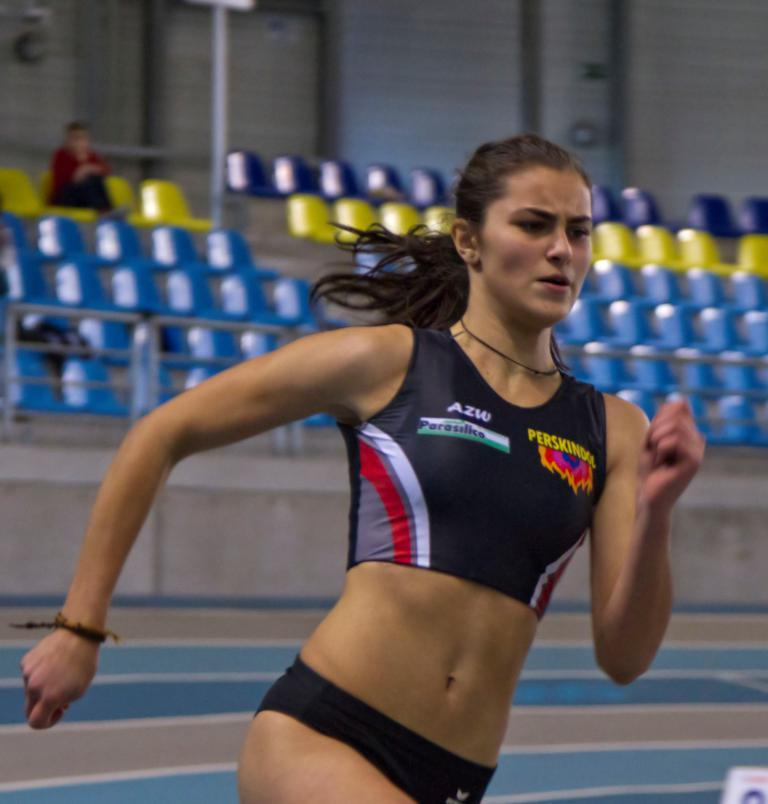<image>
Relay a brief, clear account of the picture shown. Athlete wearing a black AZW top running in a race. 